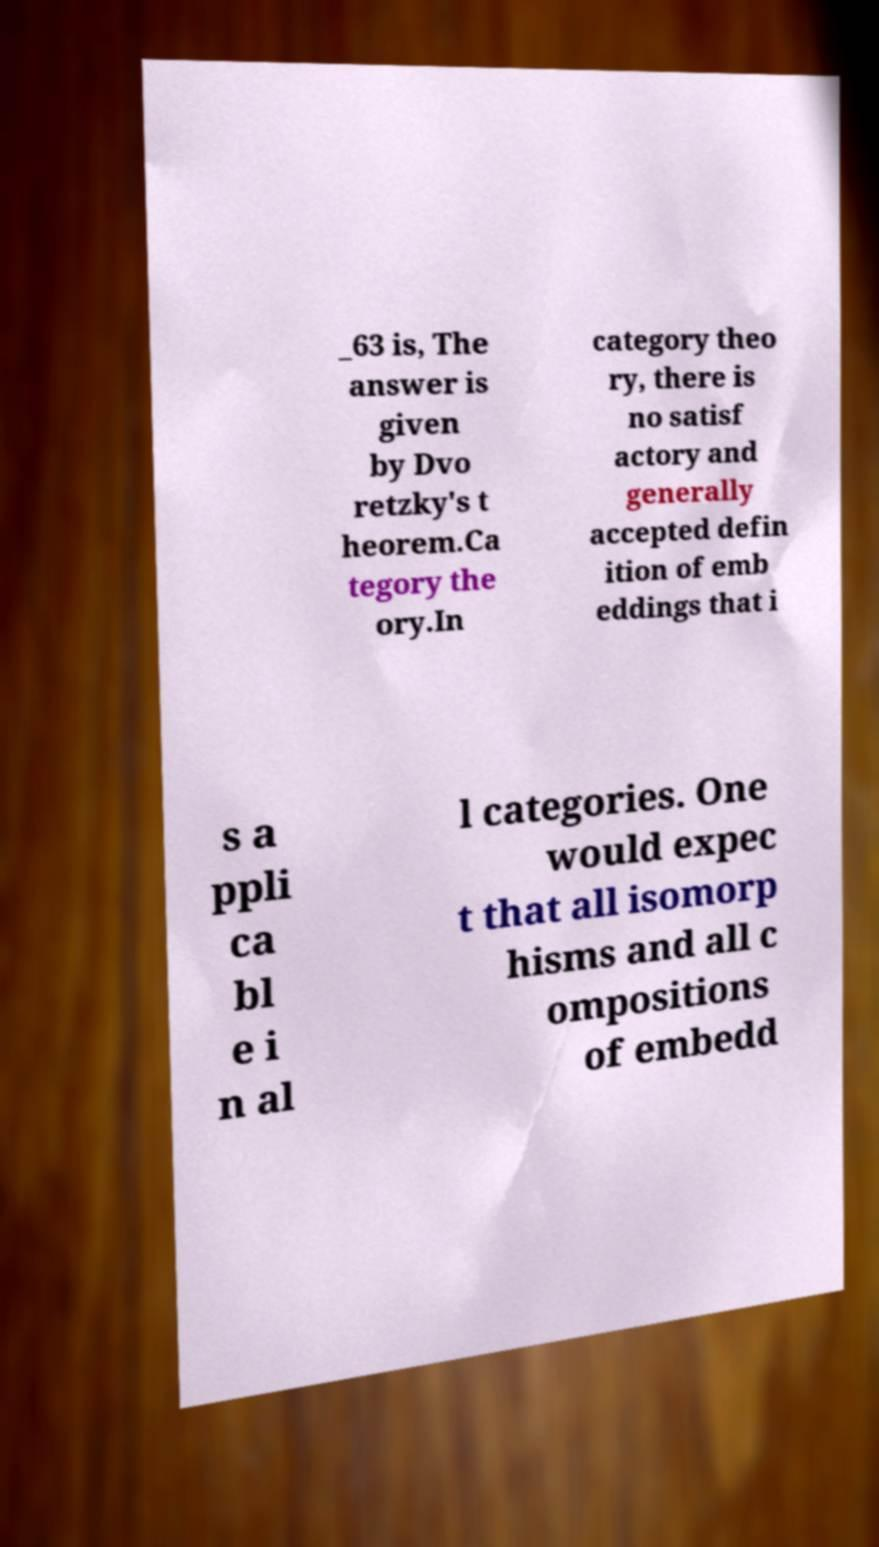For documentation purposes, I need the text within this image transcribed. Could you provide that? _63 is, The answer is given by Dvo retzky's t heorem.Ca tegory the ory.In category theo ry, there is no satisf actory and generally accepted defin ition of emb eddings that i s a ppli ca bl e i n al l categories. One would expec t that all isomorp hisms and all c ompositions of embedd 